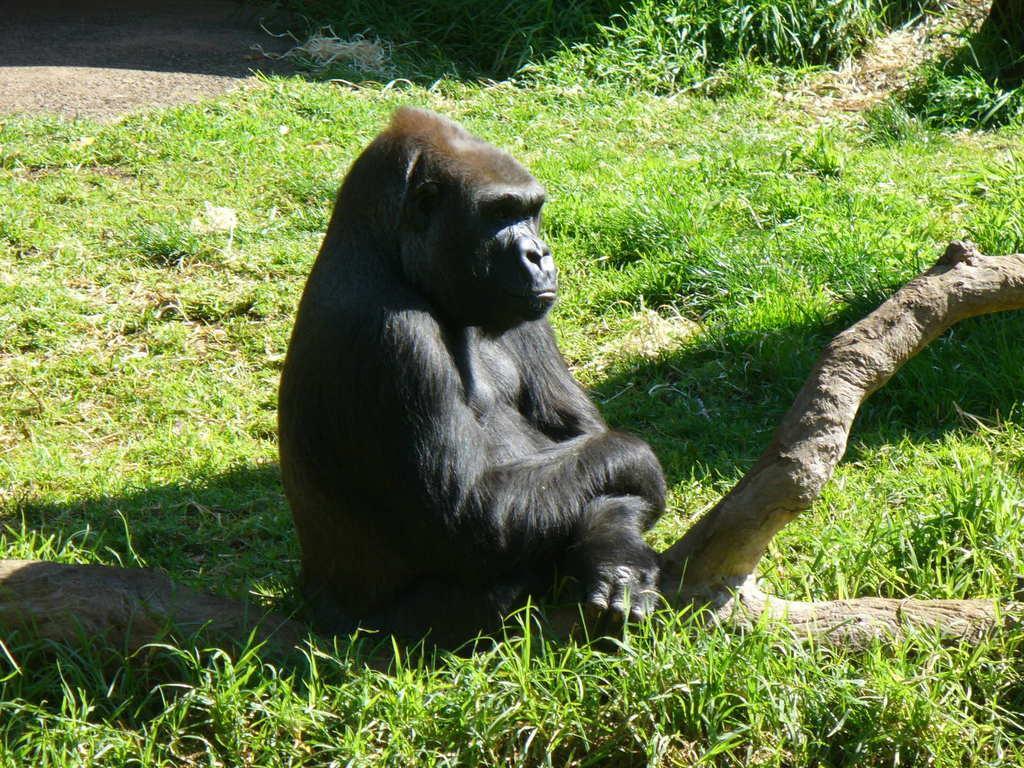In one or two sentences, can you explain what this image depicts? In the center of the image, we can see a chimpanzee on the branch and in the background, there is ground covered with grass. 